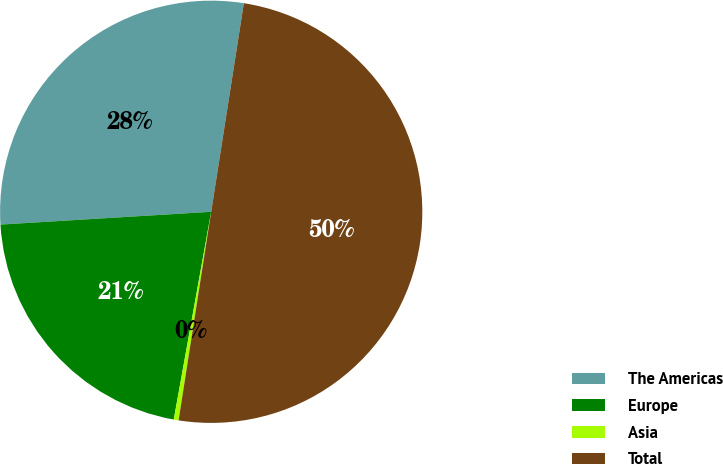<chart> <loc_0><loc_0><loc_500><loc_500><pie_chart><fcel>The Americas<fcel>Europe<fcel>Asia<fcel>Total<nl><fcel>28.44%<fcel>21.2%<fcel>0.37%<fcel>50.0%<nl></chart> 